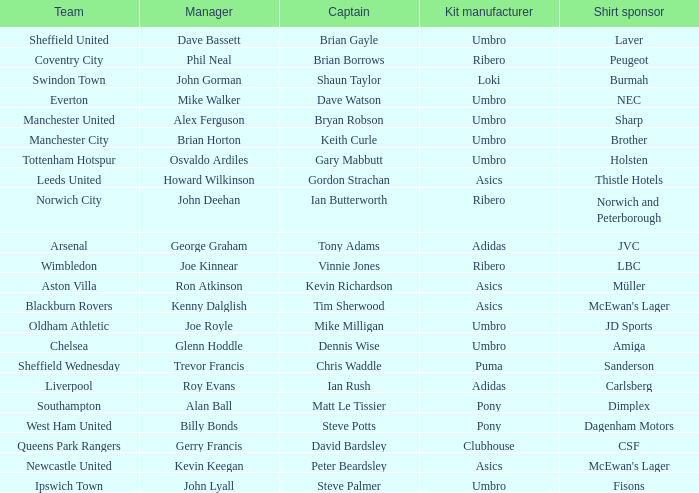What is the kit manufacturer that has billy bonds as the manager? Pony. 